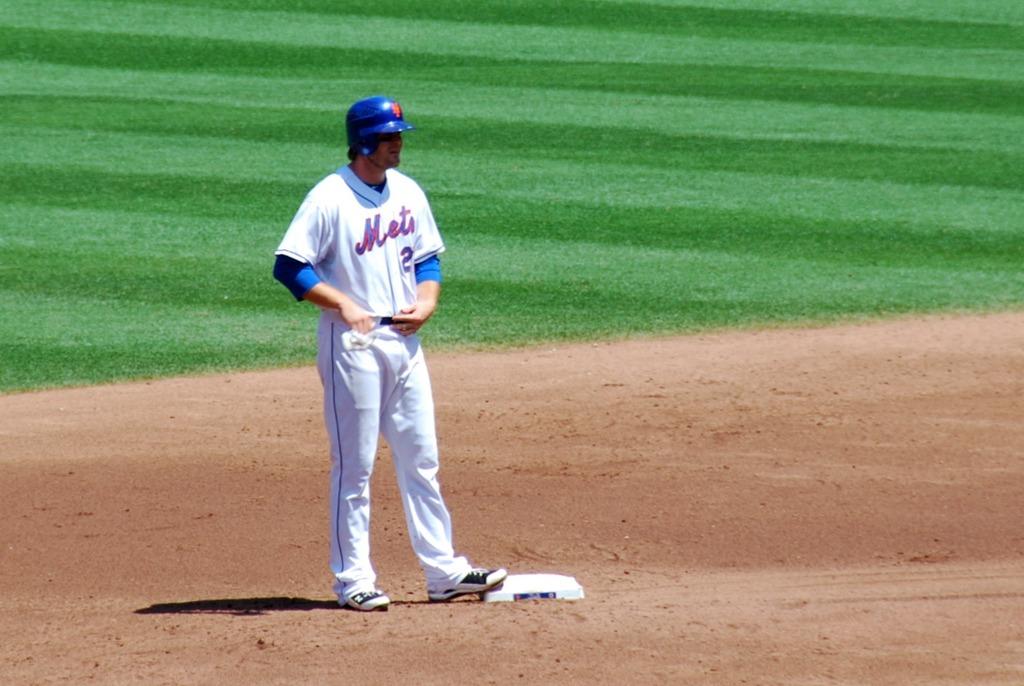What team does the baseball player play for?
Your answer should be compact. Mets. What number is he wearing?
Offer a very short reply. 2. 